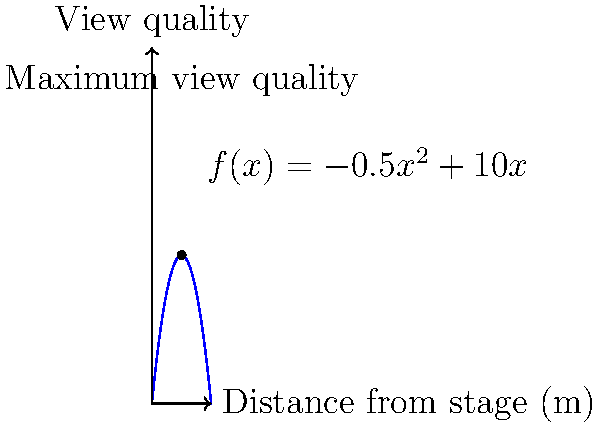As the student leader organizing the podcast host's live talk, you want to optimize the seating arrangement in the auditorium to ensure the best view quality for attendees. The view quality $f(x)$ (on a scale of 0 to 100) as a function of distance $x$ (in meters) from the stage is given by $f(x) = -0.5x^2 + 10x$. What is the optimal distance from the stage to achieve the maximum view quality, and what is this maximum view quality? To find the optimal distance and maximum view quality, we need to follow these steps:

1) The function $f(x) = -0.5x^2 + 10x$ represents a parabola opening downward.

2) To find the maximum point, we need to find where the derivative $f'(x)$ equals zero:

   $f'(x) = -x + 10$

3) Set $f'(x) = 0$ and solve for $x$:
   
   $-x + 10 = 0$
   $-x = -10$
   $x = 10$

4) This critical point $(x = 10)$ gives us the optimal distance from the stage.

5) To find the maximum view quality, we substitute $x = 10$ into the original function:

   $f(10) = -0.5(10)^2 + 10(10)$
          $= -0.5(100) + 100$
          $= -50 + 100$
          $= 50$

Therefore, the optimal distance from the stage is 10 meters, and the maximum view quality at this distance is 50.
Answer: Optimal distance: 10 meters; Maximum view quality: 50 